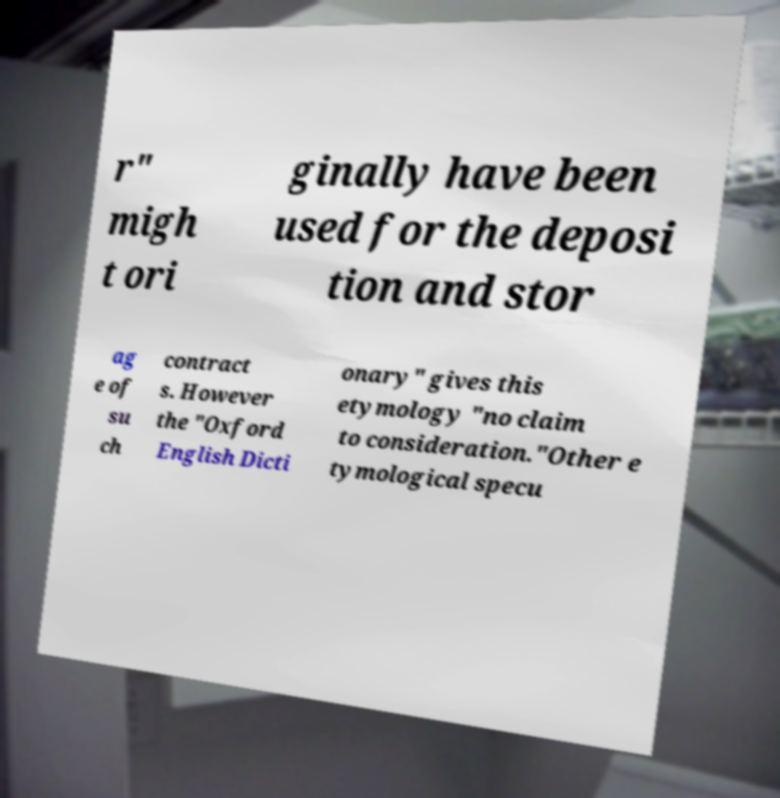I need the written content from this picture converted into text. Can you do that? r" migh t ori ginally have been used for the deposi tion and stor ag e of su ch contract s. However the "Oxford English Dicti onary" gives this etymology "no claim to consideration."Other e tymological specu 